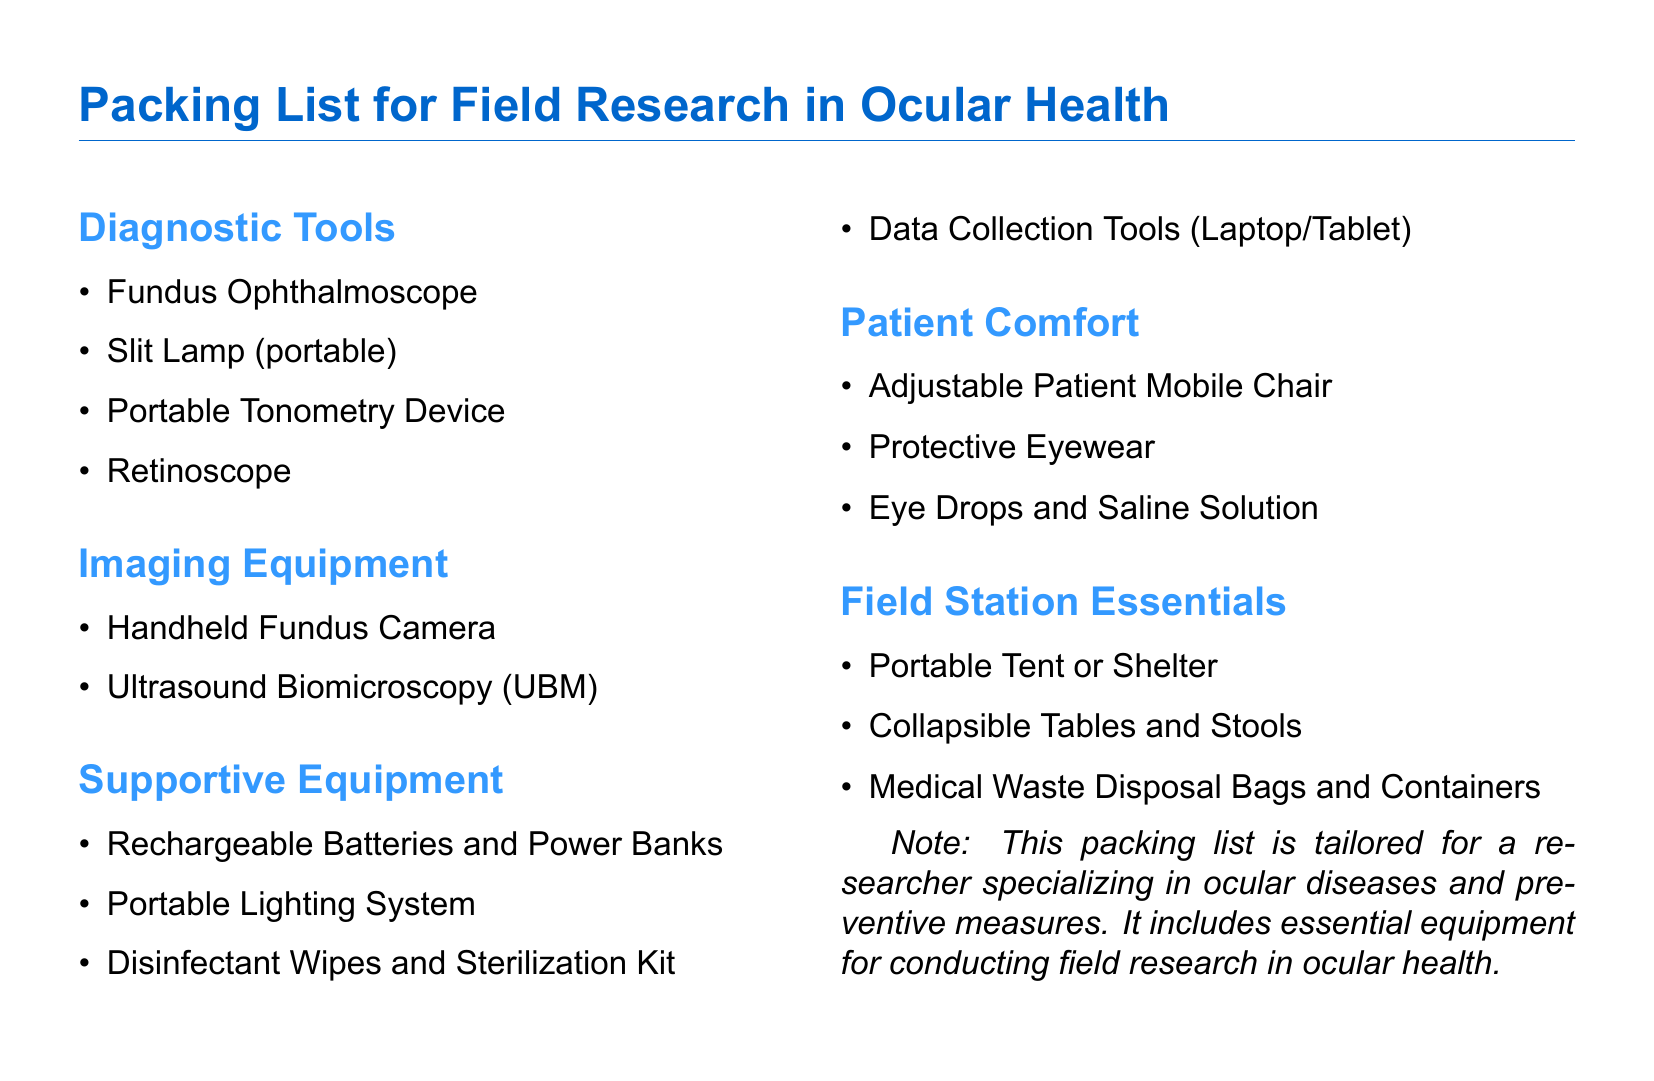What diagnostic tool is used for examining the fundus? The document lists the Fundus Ophthalmoscope as a diagnostic tool for examining the fundus.
Answer: Fundus Ophthalmoscope How many types of imaging equipment are listed? There are two types of imaging equipment mentioned: Handheld Fundus Camera and Ultrasound Biomicroscopy.
Answer: 2 What item is included for patient comfort? The packing list includes several items for patient comfort, including adjustable chairs and protective eyewear.
Answer: Adjustable Patient Mobile Chair Which portable device is listed for measuring intraocular pressure? The Portable Tonometry Device is mentioned specifically for measuring intraocular pressure.
Answer: Portable Tonometry Device What type of waste disposal is included in the field station essentials? The document specifies Medical Waste Disposal Bags and Containers in the field station essentials.
Answer: Medical Waste Disposal Bags and Containers What essential equipment assists with data collection? The packing list includes Data Collection Tools such as a Laptop or Tablet to assist with data collection.
Answer: Data Collection Tools (Laptop/Tablet) How many items are listed under Supportive Equipment? There are four items listed under Supportive Equipment: Rechargeable Batteries, Portable Lighting System, Disinfectant Wipes, and Data Collection Tools.
Answer: 4 What is the purpose of the disinfectant wipes mentioned? The disinfectant wipes are included in the supportive equipment for sterilization purposes.
Answer: Sterilization What kind of lighting equipment is mentioned? A Portable Lighting System is included in the list of supportive equipment.
Answer: Portable Lighting System 